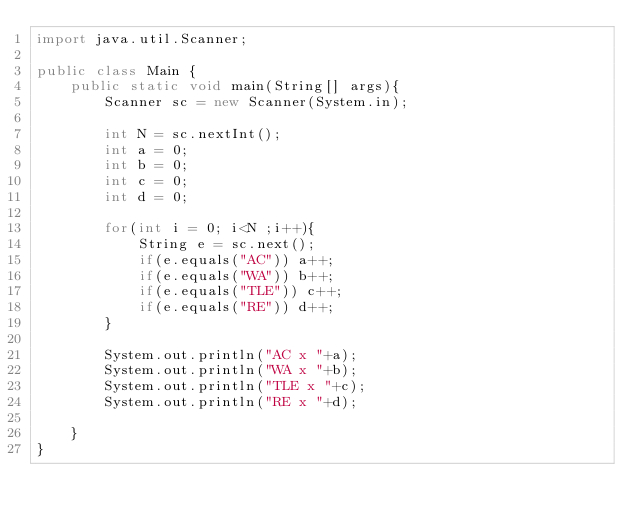<code> <loc_0><loc_0><loc_500><loc_500><_Java_>import java.util.Scanner; 

public class Main {
    public static void main(String[] args){
        Scanner sc = new Scanner(System.in);

        int N = sc.nextInt();
        int a = 0;
        int b = 0;
        int c = 0;
        int d = 0;

        for(int i = 0; i<N ;i++){
            String e = sc.next();
            if(e.equals("AC")) a++;
            if(e.equals("WA")) b++;
            if(e.equals("TLE")) c++;
            if(e.equals("RE")) d++;
        }

        System.out.println("AC x "+a);
        System.out.println("WA x "+b);
        System.out.println("TLE x "+c);
        System.out.println("RE x "+d);       

    }
}</code> 